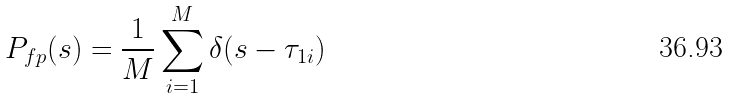<formula> <loc_0><loc_0><loc_500><loc_500>P _ { f p } ( s ) = \frac { 1 } { M } \sum _ { i = 1 } ^ { M } \delta ( s - \tau _ { 1 i } )</formula> 